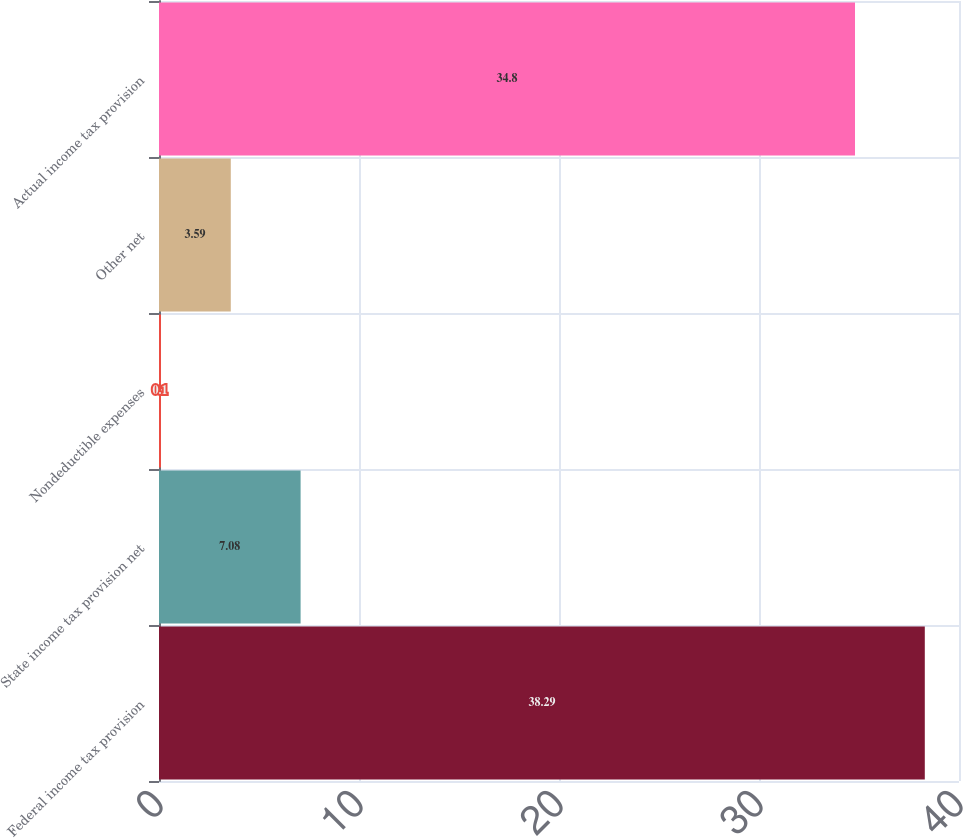<chart> <loc_0><loc_0><loc_500><loc_500><bar_chart><fcel>Federal income tax provision<fcel>State income tax provision net<fcel>Nondeductible expenses<fcel>Other net<fcel>Actual income tax provision<nl><fcel>38.29<fcel>7.08<fcel>0.1<fcel>3.59<fcel>34.8<nl></chart> 